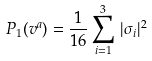Convert formula to latex. <formula><loc_0><loc_0><loc_500><loc_500>P _ { 1 } ( v ^ { a } ) = \frac { 1 } { 1 6 } \sum _ { i = 1 } ^ { 3 } \, { | \sigma _ { i } | ^ { 2 } }</formula> 